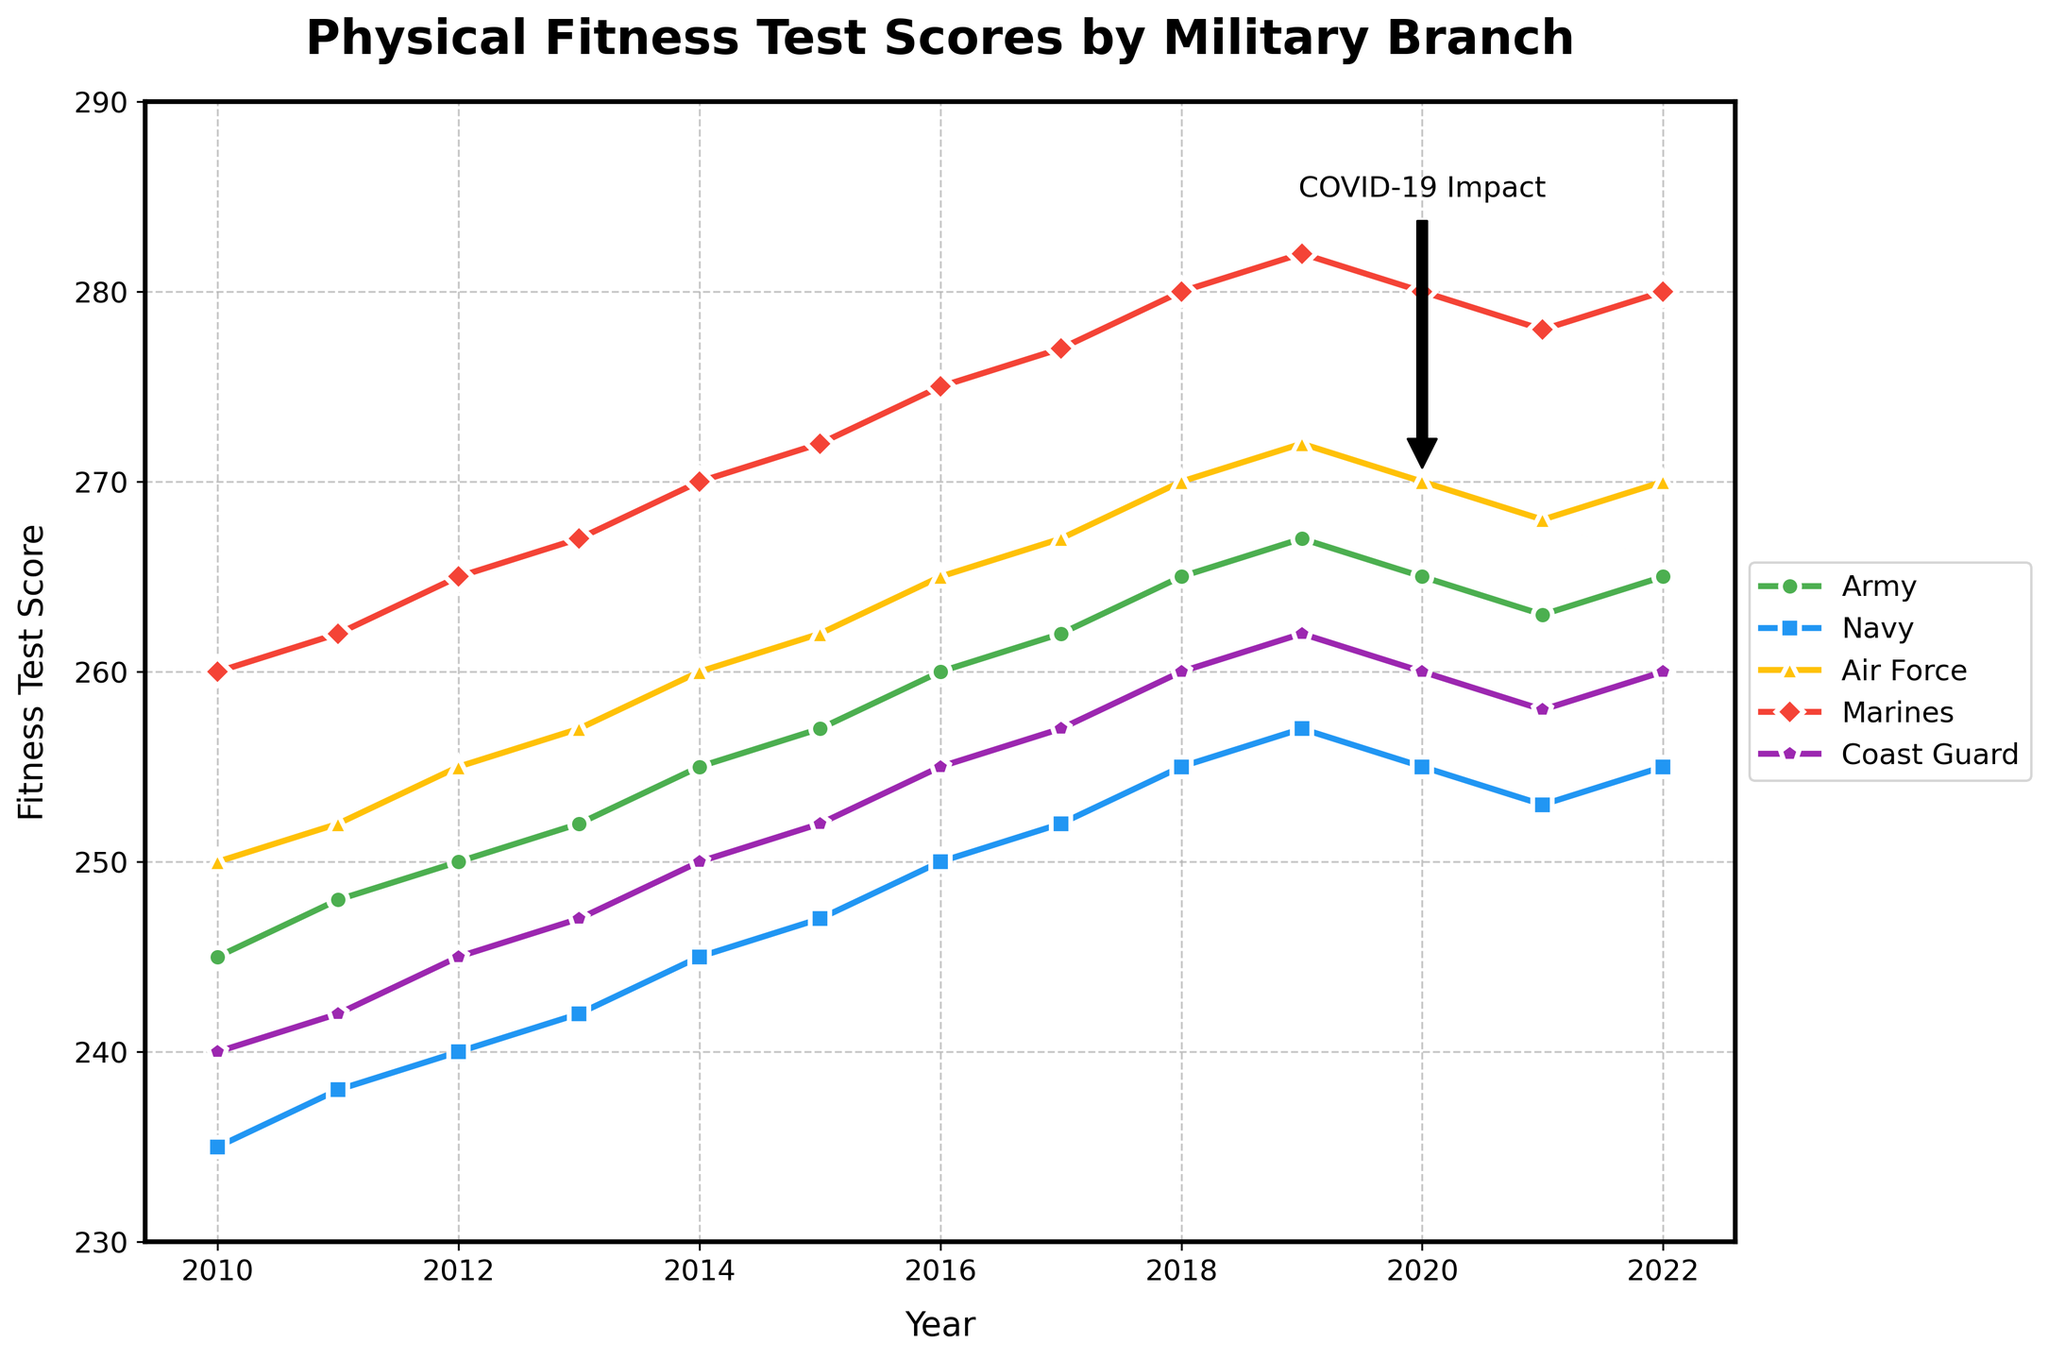what does the trend in fitness test scores for the Marines look like from 2010 to 2022? The curve representing the Marines in red shows an upward trend from 2010 to 2019, with scores increasing from 260 to 282. There is a slight decrease in 2020 to 280 and remains the same till 2022.
Answer: Upward trend, then stable Which branch had the highest fitness test score in 2013? In 2013, we look at the scores for each branch and find that the Marines had the highest score. The Marines' score is 267 in 2013.
Answer: Marines Has the Army's fitness test score ever surpassed 265 between 2010 and 2022? Looking at the Army's line, the scores surpassed 265 only from 2018 to 2019, where they reached 265 and 267.
Answer: Yes, from 2018 to 2019 Which year did the Coast Guard's fitness test scores equal 255? Looking at the Coast Guard's line, the score of 255 was achieved in 2016 and 2022.
Answer: 2016 and 2022 By how many points did the fitness test score for the Navy increase from 2010 to 2022? The Navy's score in 2010 is 235 and in 2022 it is 255. The increase can be calculated as 255 - 235.
Answer: 20 points What is the overall trend for the Air Force from 2010 to 2022? Observing the Air Force's yellow line, it generally follows an upward trend from 250 to 270 from 2010 to 2022, with minor fluctuations.
Answer: Upward trend During what period did all branches show the least variability in fitness scores? The scores show the least variation during the period of 2020 to 2022 when all branches' scores are more stable and do not change drastically.
Answer: 2020-2022 What is the difference in the fitness test scores between the Marines and the Coast Guard in 2015? In 2015, the Marines scored 272 and the Coast Guard scored 252. The difference can be found by subtracting 252 from 272.
Answer: 20 points Which branch showed the most significant increase in fitness test scores between 2010 and 2019? Comparing the increases: The Marines had a score increase from 260 to 282 (20 points), which is the most significant increase among all the branches.
Answer: Marines What’s the average change in fitness test scores for the Navy from 2010 to 2022? To find the average change, we observe the Navy's line. From 2010 to 2022, the score increased from 235 to 255. The total increase is 255 - 235 = 20 points. Dividing by 12 years gives an average change.
Answer: 1.67 points per year 